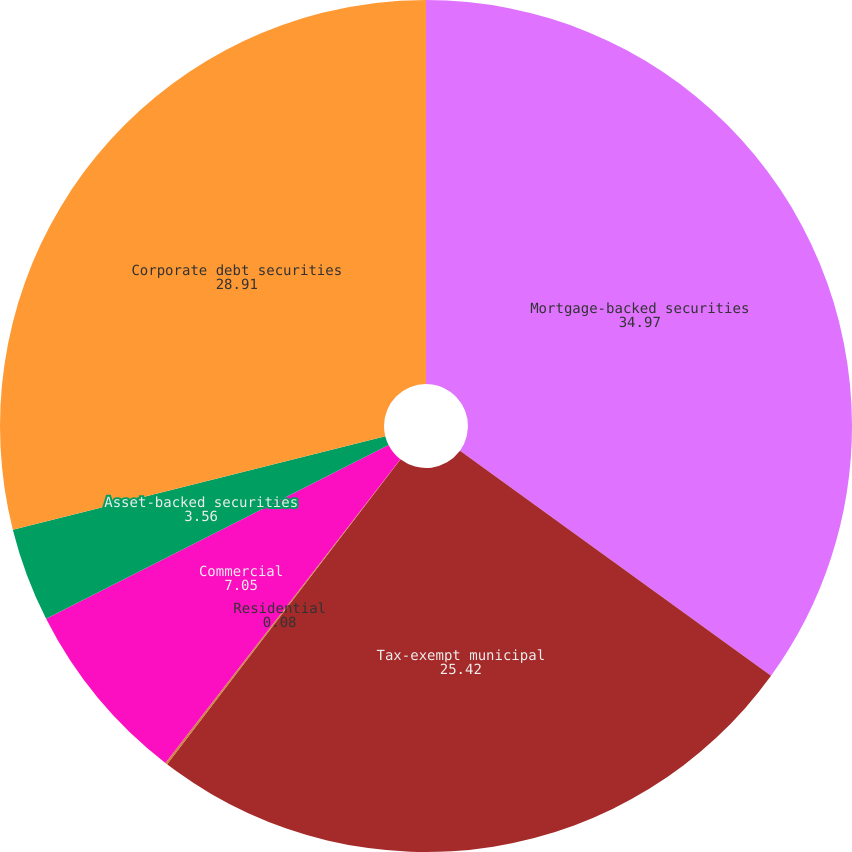<chart> <loc_0><loc_0><loc_500><loc_500><pie_chart><fcel>Mortgage-backed securities<fcel>Tax-exempt municipal<fcel>Residential<fcel>Commercial<fcel>Asset-backed securities<fcel>Corporate debt securities<nl><fcel>34.97%<fcel>25.42%<fcel>0.08%<fcel>7.05%<fcel>3.56%<fcel>28.91%<nl></chart> 